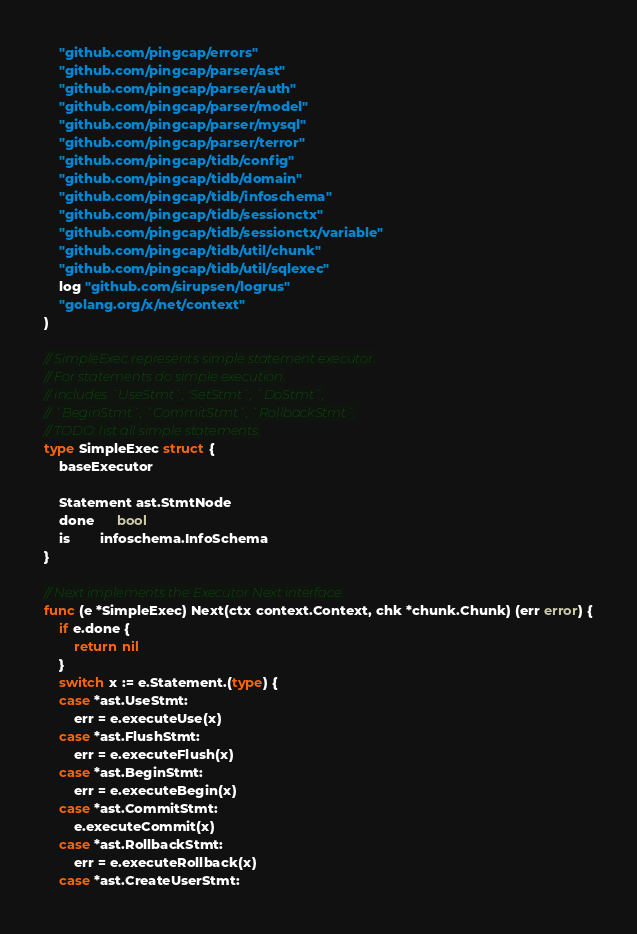<code> <loc_0><loc_0><loc_500><loc_500><_Go_>
	"github.com/pingcap/errors"
	"github.com/pingcap/parser/ast"
	"github.com/pingcap/parser/auth"
	"github.com/pingcap/parser/model"
	"github.com/pingcap/parser/mysql"
	"github.com/pingcap/parser/terror"
	"github.com/pingcap/tidb/config"
	"github.com/pingcap/tidb/domain"
	"github.com/pingcap/tidb/infoschema"
	"github.com/pingcap/tidb/sessionctx"
	"github.com/pingcap/tidb/sessionctx/variable"
	"github.com/pingcap/tidb/util/chunk"
	"github.com/pingcap/tidb/util/sqlexec"
	log "github.com/sirupsen/logrus"
	"golang.org/x/net/context"
)

// SimpleExec represents simple statement executor.
// For statements do simple execution.
// includes `UseStmt`, 'SetStmt`, `DoStmt`,
// `BeginStmt`, `CommitStmt`, `RollbackStmt`.
// TODO: list all simple statements.
type SimpleExec struct {
	baseExecutor

	Statement ast.StmtNode
	done      bool
	is        infoschema.InfoSchema
}

// Next implements the Executor Next interface.
func (e *SimpleExec) Next(ctx context.Context, chk *chunk.Chunk) (err error) {
	if e.done {
		return nil
	}
	switch x := e.Statement.(type) {
	case *ast.UseStmt:
		err = e.executeUse(x)
	case *ast.FlushStmt:
		err = e.executeFlush(x)
	case *ast.BeginStmt:
		err = e.executeBegin(x)
	case *ast.CommitStmt:
		e.executeCommit(x)
	case *ast.RollbackStmt:
		err = e.executeRollback(x)
	case *ast.CreateUserStmt:</code> 